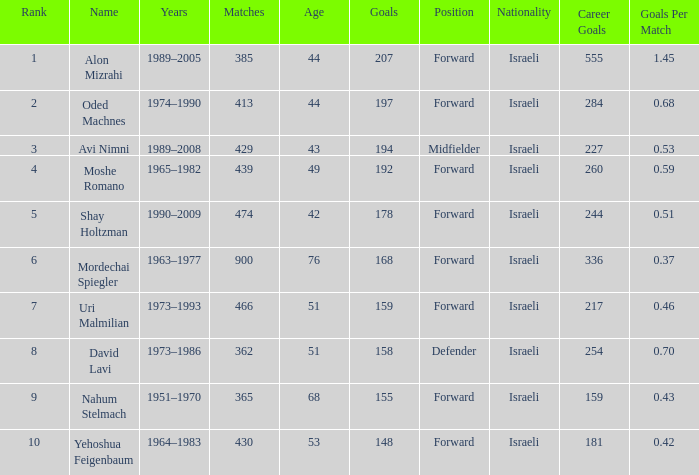What is the Rank of the player with 362 Matches? 8.0. 